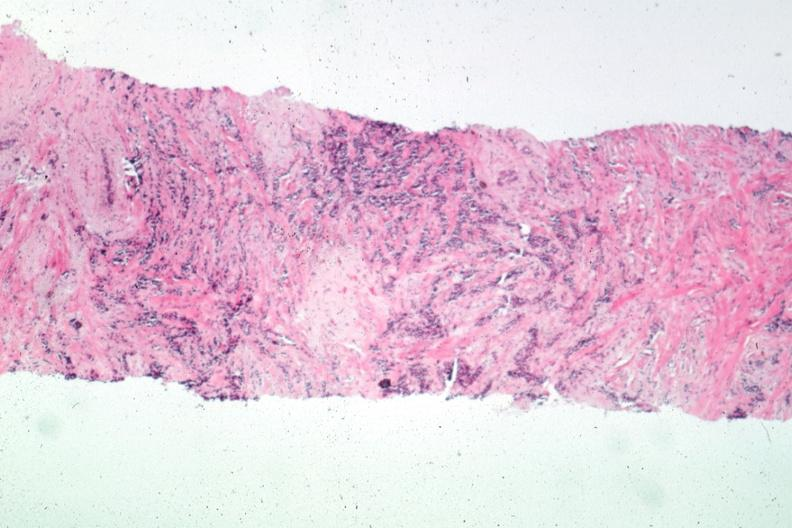s subdiaphragmatic abscess present?
Answer the question using a single word or phrase. No 